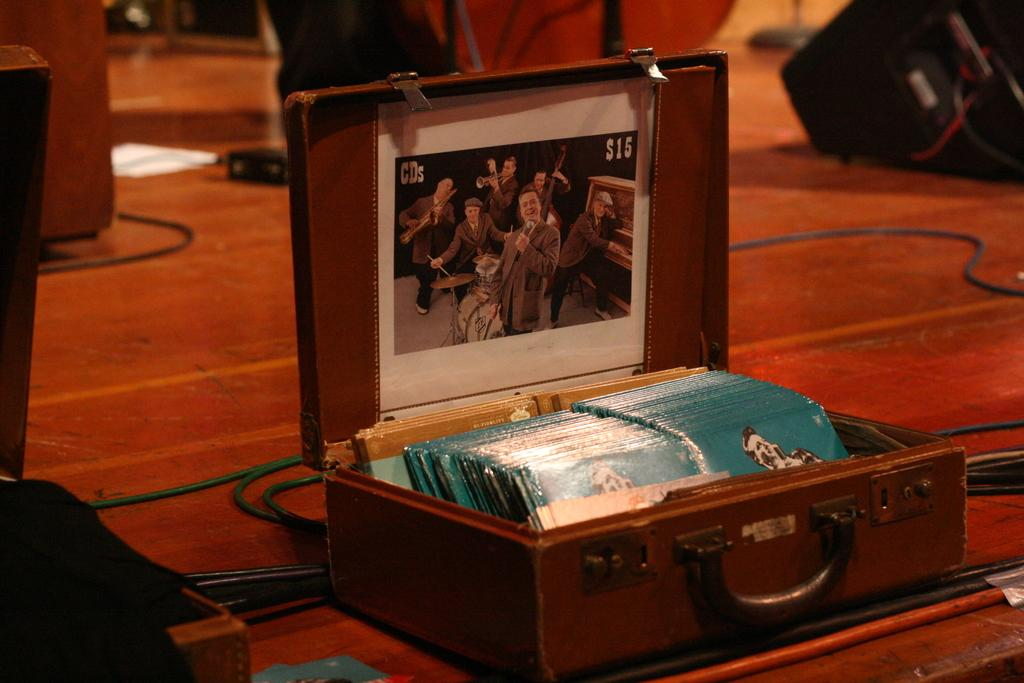What is the main object in the image? There is a photocopy in the image. What else can be seen in the image besides the photocopy? There are boxes in a suitcase and a wire visible in the image. Can you describe the device in the image? Unfortunately, the facts provided do not give enough information to describe the device in the image. Where is the baby playing in the image? There is no baby present in the image. What type of cemetery can be seen in the background of the image? There is no cemetery present in the image. 